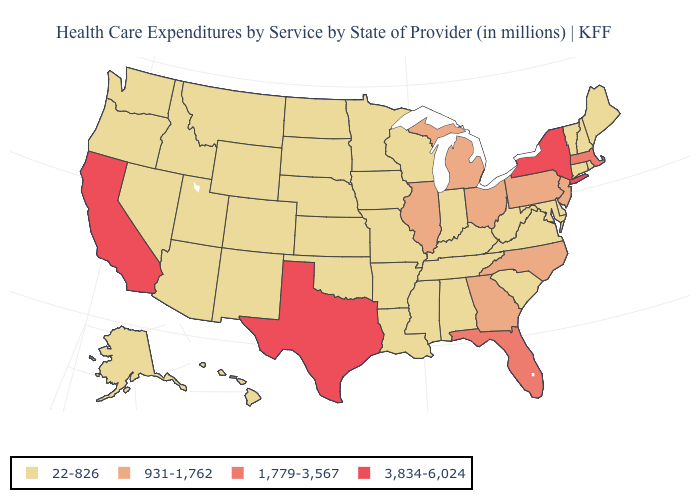What is the lowest value in the West?
Quick response, please. 22-826. Does the first symbol in the legend represent the smallest category?
Write a very short answer. Yes. Name the states that have a value in the range 22-826?
Keep it brief. Alabama, Alaska, Arizona, Arkansas, Colorado, Connecticut, Delaware, Hawaii, Idaho, Indiana, Iowa, Kansas, Kentucky, Louisiana, Maine, Maryland, Minnesota, Mississippi, Missouri, Montana, Nebraska, Nevada, New Hampshire, New Mexico, North Dakota, Oklahoma, Oregon, Rhode Island, South Carolina, South Dakota, Tennessee, Utah, Vermont, Virginia, Washington, West Virginia, Wisconsin, Wyoming. Name the states that have a value in the range 1,779-3,567?
Be succinct. Florida, Massachusetts. What is the highest value in the USA?
Short answer required. 3,834-6,024. Name the states that have a value in the range 22-826?
Concise answer only. Alabama, Alaska, Arizona, Arkansas, Colorado, Connecticut, Delaware, Hawaii, Idaho, Indiana, Iowa, Kansas, Kentucky, Louisiana, Maine, Maryland, Minnesota, Mississippi, Missouri, Montana, Nebraska, Nevada, New Hampshire, New Mexico, North Dakota, Oklahoma, Oregon, Rhode Island, South Carolina, South Dakota, Tennessee, Utah, Vermont, Virginia, Washington, West Virginia, Wisconsin, Wyoming. Among the states that border New Jersey , does Pennsylvania have the lowest value?
Write a very short answer. No. Name the states that have a value in the range 1,779-3,567?
Be succinct. Florida, Massachusetts. What is the value of Indiana?
Keep it brief. 22-826. How many symbols are there in the legend?
Concise answer only. 4. What is the highest value in states that border Iowa?
Quick response, please. 931-1,762. Among the states that border New Jersey , does Delaware have the lowest value?
Keep it brief. Yes. What is the value of Wisconsin?
Quick response, please. 22-826. What is the lowest value in the USA?
Be succinct. 22-826. 